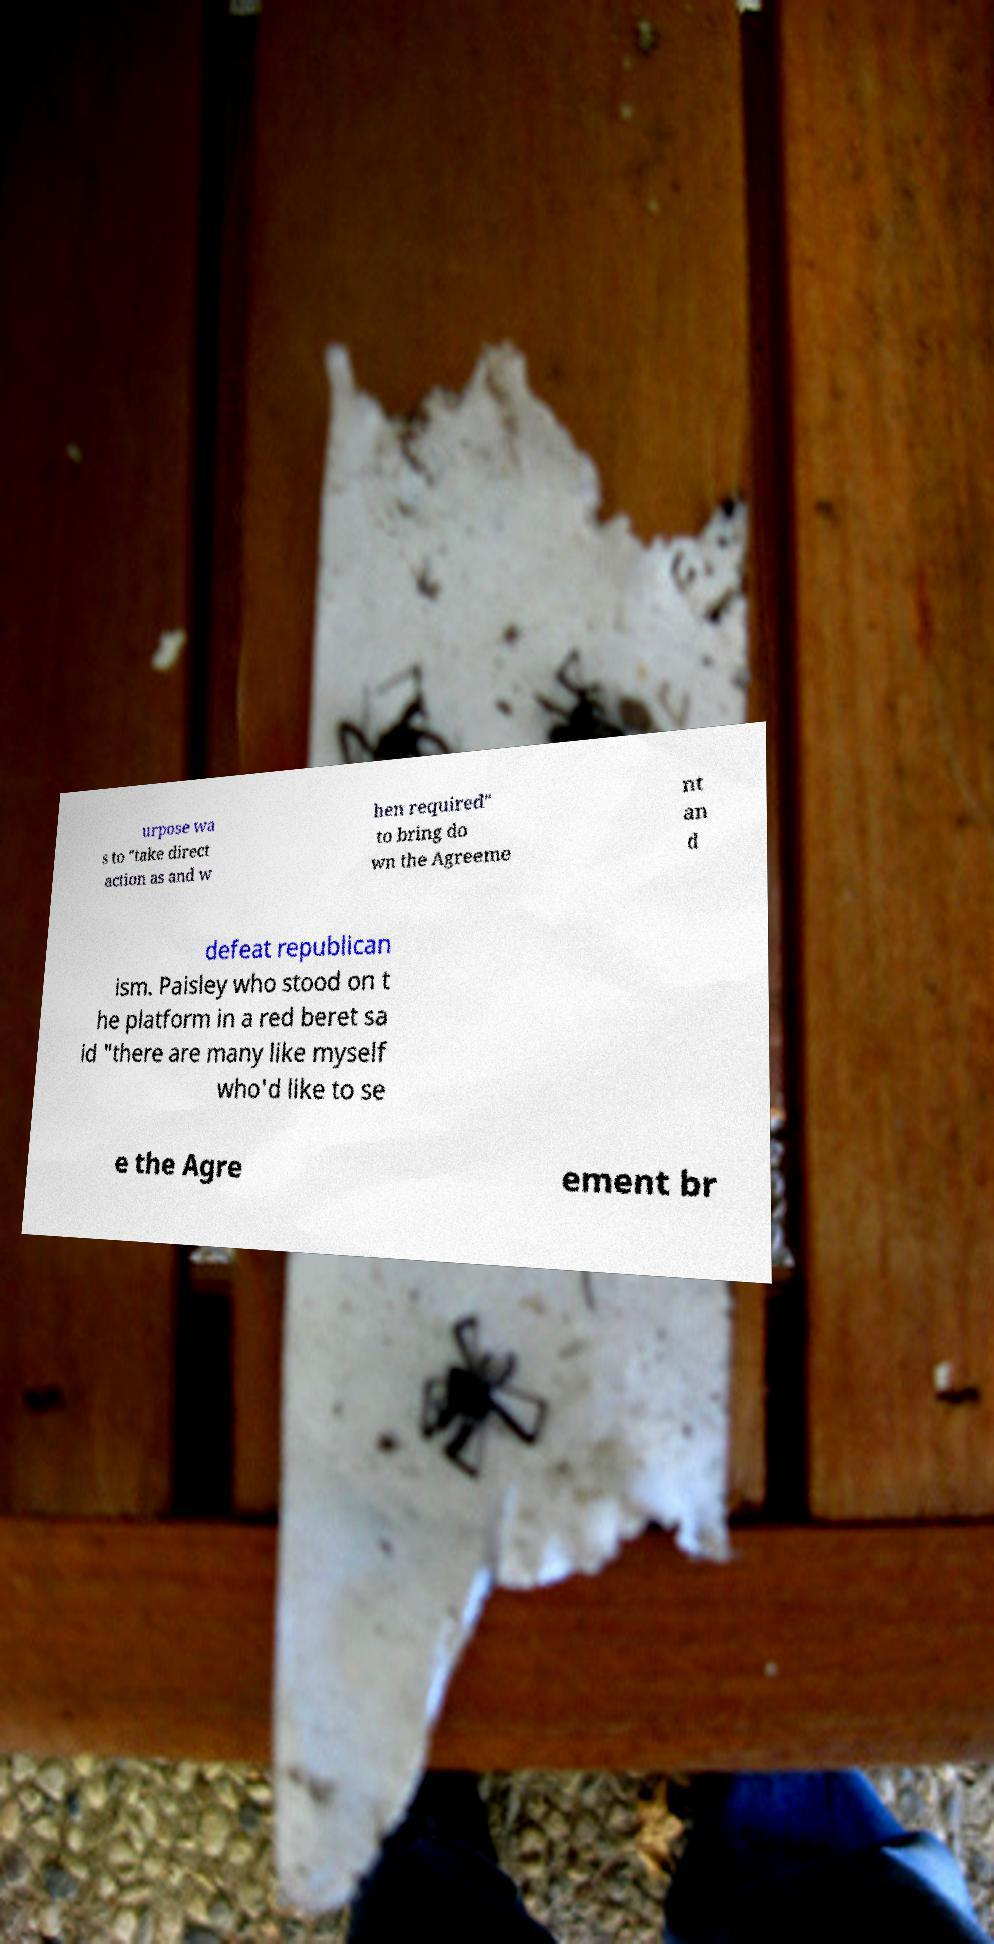Could you assist in decoding the text presented in this image and type it out clearly? urpose wa s to "take direct action as and w hen required" to bring do wn the Agreeme nt an d defeat republican ism. Paisley who stood on t he platform in a red beret sa id "there are many like myself who'd like to se e the Agre ement br 